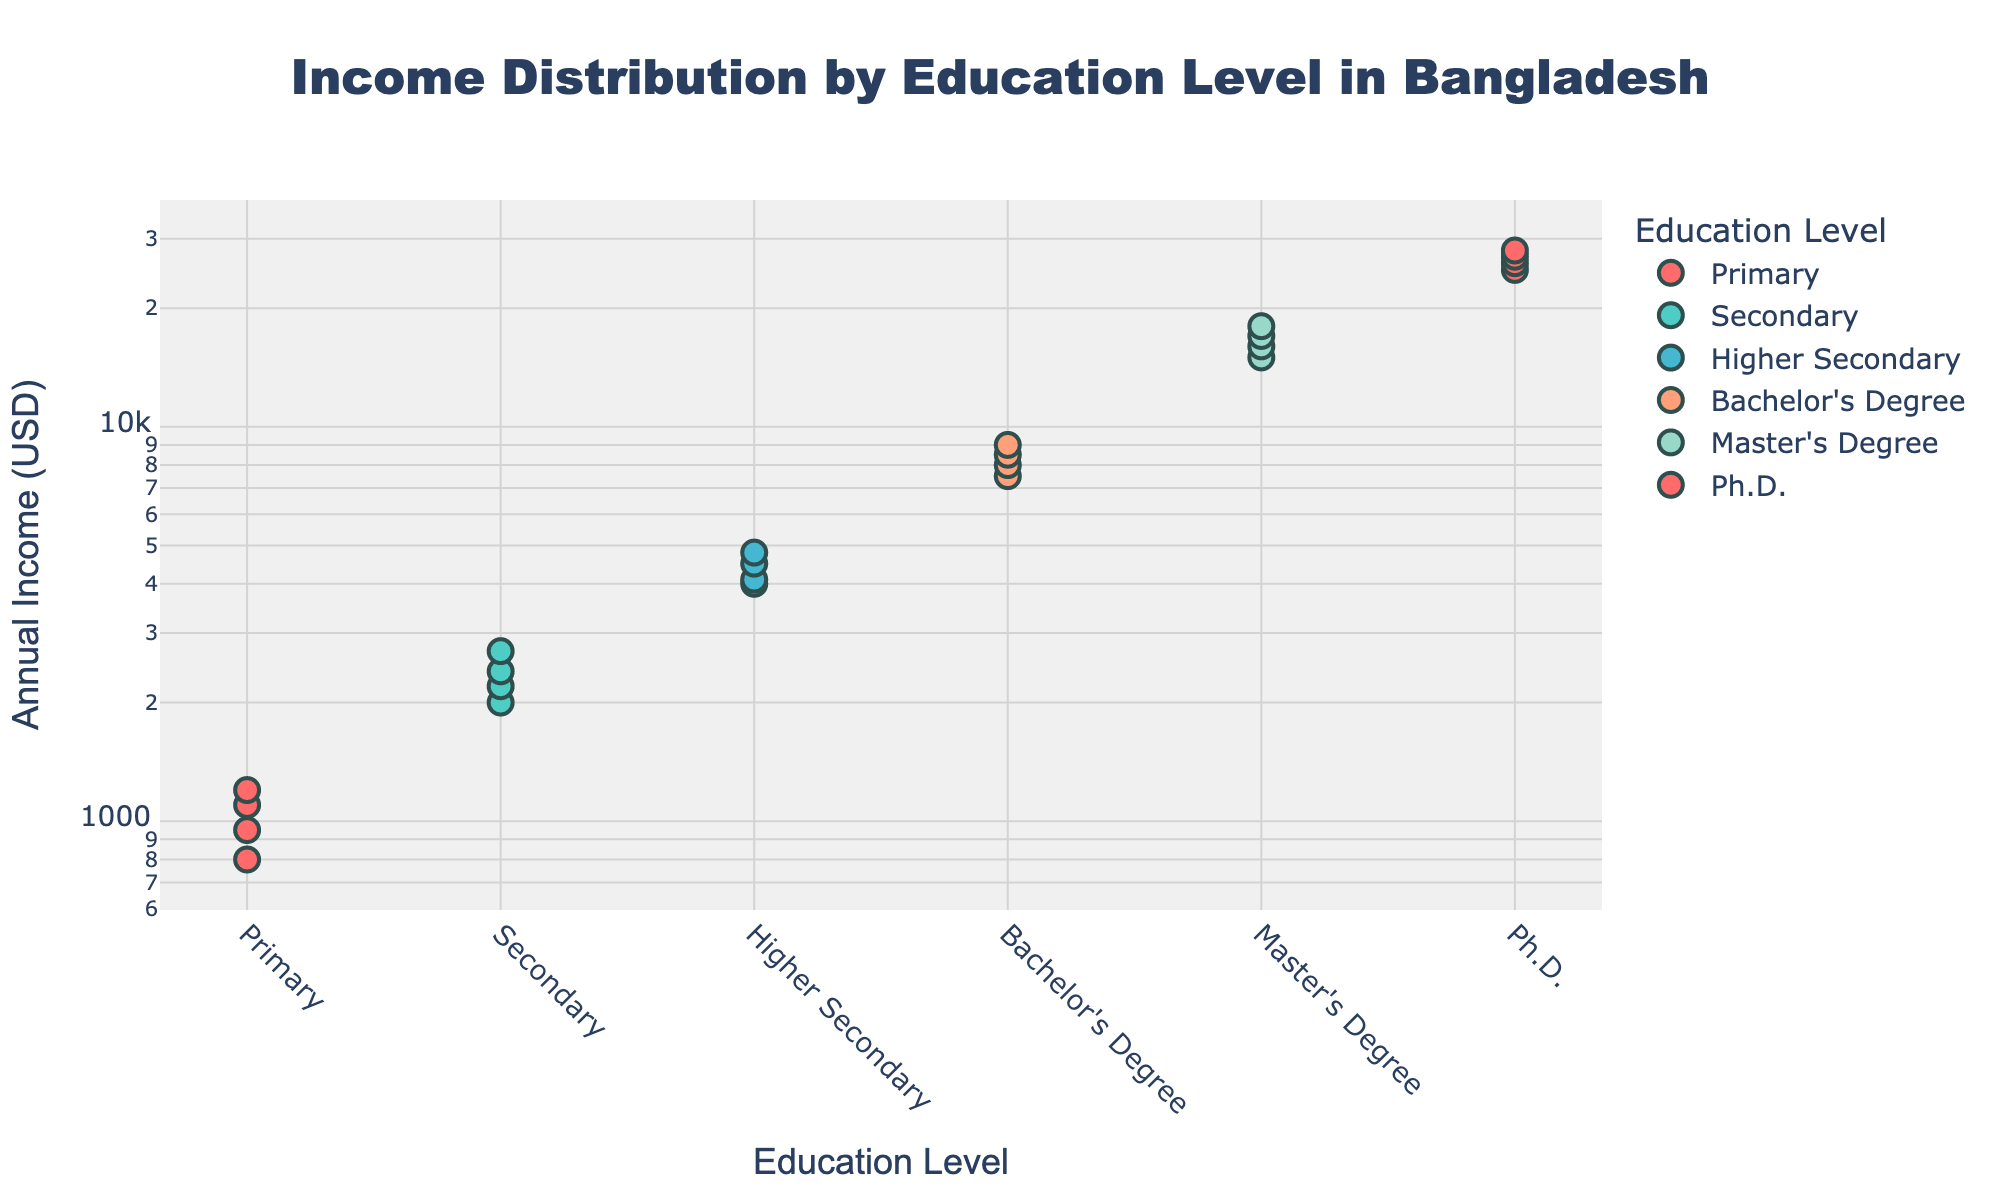What's the title of the plot? The title is usually positioned at the top center of the plot. It is a textual description that summarizes what the plot is about.
Answer: Income Distribution by Education Level in Bangladesh What is the unit of the y-axis? The y-axis is labeled with the title to indicate the measurement unit, which in this case, denotes the annual income in U.S. dollars.
Answer: Annual Income (USD) Which education level has the widest spread of annual income values? To find this, observe the range (difference between the highest and lowest values) along the y-axis for each education level. The 'Ph.D.' category spans a significant range from 25,000 to 28,000 USD.
Answer: Ph.D How many data points are there for Bachelor's Degree? Count the number of markers corresponding to the Bachelor's Degree on the plot.
Answer: 4 Which education level has data points with the highest annual income? Identify the highest point along the y-axis and note the corresponding education level. The highest income data points are for individuals with Ph.D. degrees, above 25,000 USD.
Answer: Ph.D What's the minimum and maximum annual income for Secondary education? Examine the markers for 'Secondary' education and note the smallest and largest values along the y-axis. The minimum is 2,000 USD and the maximum is 2,700 USD.
Answer: 2,000 USD, 2,700 USD What is the dominant color used for Master's Degree markers? Each education level is represented with a unique color for easy identification. Identify the color used for Master's Degree markers on the plot.
Answer: Light Blue (approximately) Between which education levels is the change in median annual income most significant? The median is the middle value of the dataset for each education level. Comparing median values, the change is most significant between Bachelor’s Degree and Master’s Degree.
Answer: Bachelor's Degree to Master's Degree Is there any education level that has consistent income values with little variation? Check for a narrow range of income values for any education level. 'Primary' education markers show a relatively consistent range around 800 to 1200 USD.
Answer: Primary Explain why a log scale might be used for the y-axis in this plot. A log scale is used to handle a wide range of data values and to better visualize data that spans several orders of magnitude. In this plot, it allows for better visualization of both lower and higher income groups. This helps in clearly displaying the income differences between education levels.
Answer: To handle wide data range and visualize income differences effectively 